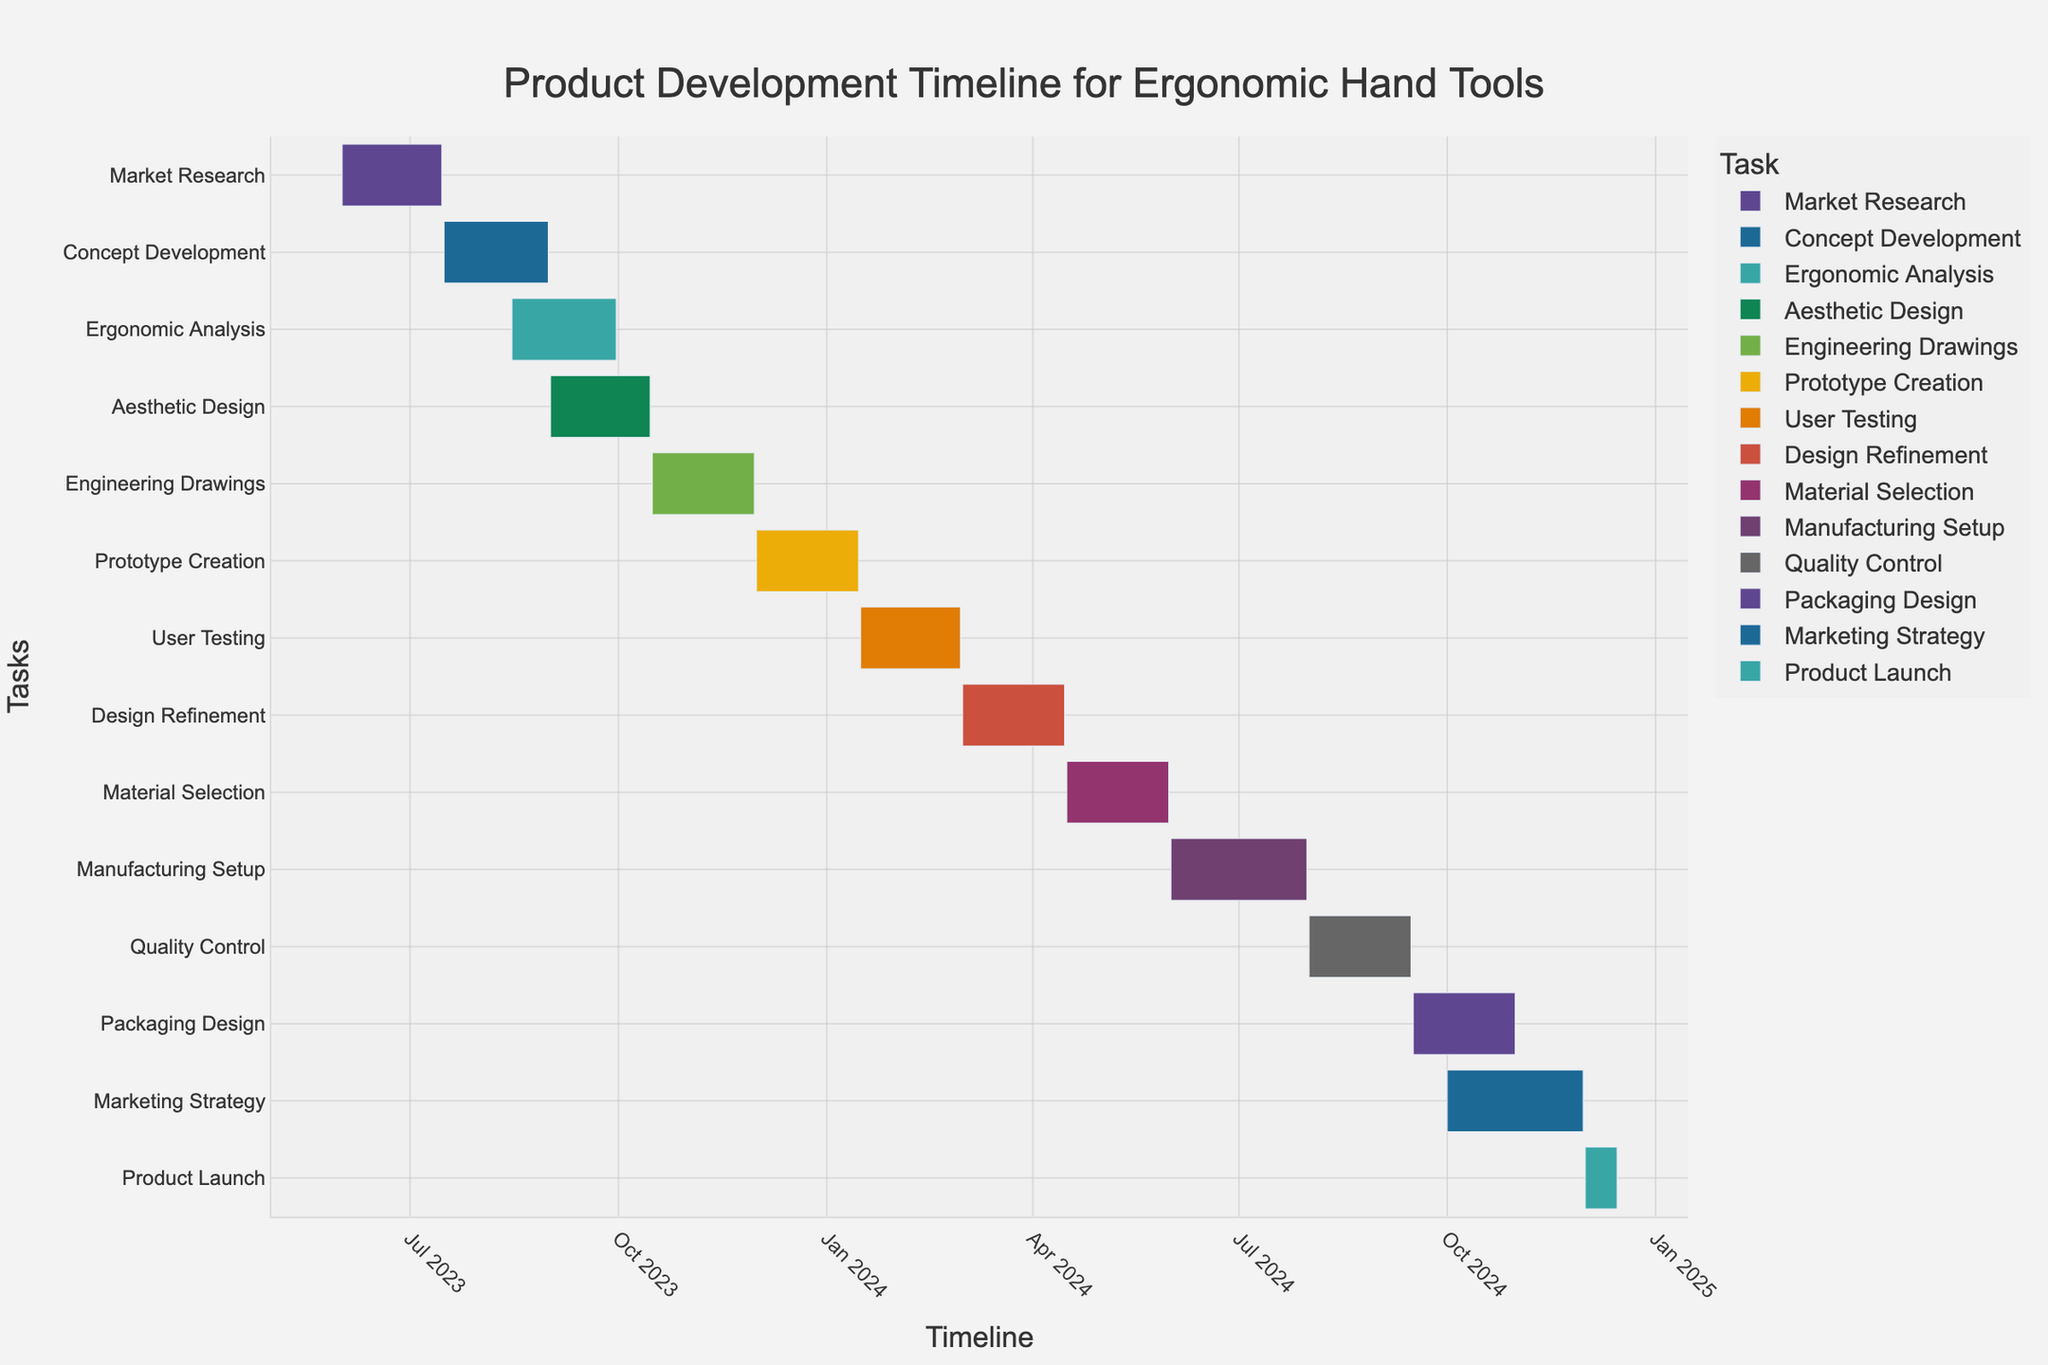Which task starts the earliest in the product development timeline? The task that starts the earliest is called "Market Research," which begins on June 1, 2023. This is identified by looking for the task with the earliest start date on the Gantt chart.
Answer: Market Research When does the "Prototype Creation" phase end? The end date for the "Prototype Creation" phase can be read directly from the Gantt chart, where the bar corresponding to "Prototype Creation" ends on January 15, 2024.
Answer: January 15, 2024 Which task has the longest duration in the timeline? By comparing the lengths of the bars, "Manufacturing Setup" covers the longest period from June 1, 2024, to July 31, 2024, resulting in a duration of 61 days.
Answer: Manufacturing Setup Are there any tasks that overlap with "Ergonomic Analysis"? The tasks that overlap with "Ergonomic Analysis" are "Concept Development" and "Aesthetic Design." "Concept Development" overlaps because it ends on August 31, 2023, and "Aesthetic Design" overlaps because it starts on September 1, 2023. The overlap with "Ergonomic Analysis" (August 15, 2023, to September 30, 2023) needs to be checked by comparing the start and end dates.
Answer: Yes, "Concept Development" and "Aesthetic Design" How long is the gap between "User Testing" and "Design Refinement"? The end date for "User Testing" is February 29, 2024, and the start date for "Design Refinement" is March 1, 2024. The difference between these dates is calculated to determine the gap. Since these dates are consecutive, there is no gap between them.
Answer: No gap What is the total duration from "Market Research" to "Product Launch"? The start date for "Market Research" is June 1, 2023, and the end date for "Product Launch" is December 15, 2024. The total duration can be calculated as the difference between these dates, which equals 563 days.
Answer: 563 days Does "Marketing Strategy" begin before "Quality Control" ends? By checking the Gantt chart, "Marketing Strategy" starts on October 1, 2024, while "Quality Control" ends on September 15, 2024. Since "Marketing Strategy" begins after "Quality Control" ends, the question confirms it.
Answer: No Which two tasks have the same duration, and what is that duration? By examining the lengths of the task bars and counting the days, both "Market Research" and "Packaging Design" have durations of 45 days.
Answer: Market Research and Packaging Design, 45 days How many tasks involve designing, based on their names? By reading through the names of the tasks, the designing-related tasks are "Aesthetic Design," "Engineering Drawings," and "Packaging Design." This gives a total of three design-related tasks.
Answer: 3 tasks Which task immediately follows "Material Selection"? The task following "Material Selection" is "Manufacturing Setup," as observed by identifying the next task bar starting on June 1, 2024, just after the end of "Material Selection" on May 31, 2024.
Answer: Manufacturing Setup 